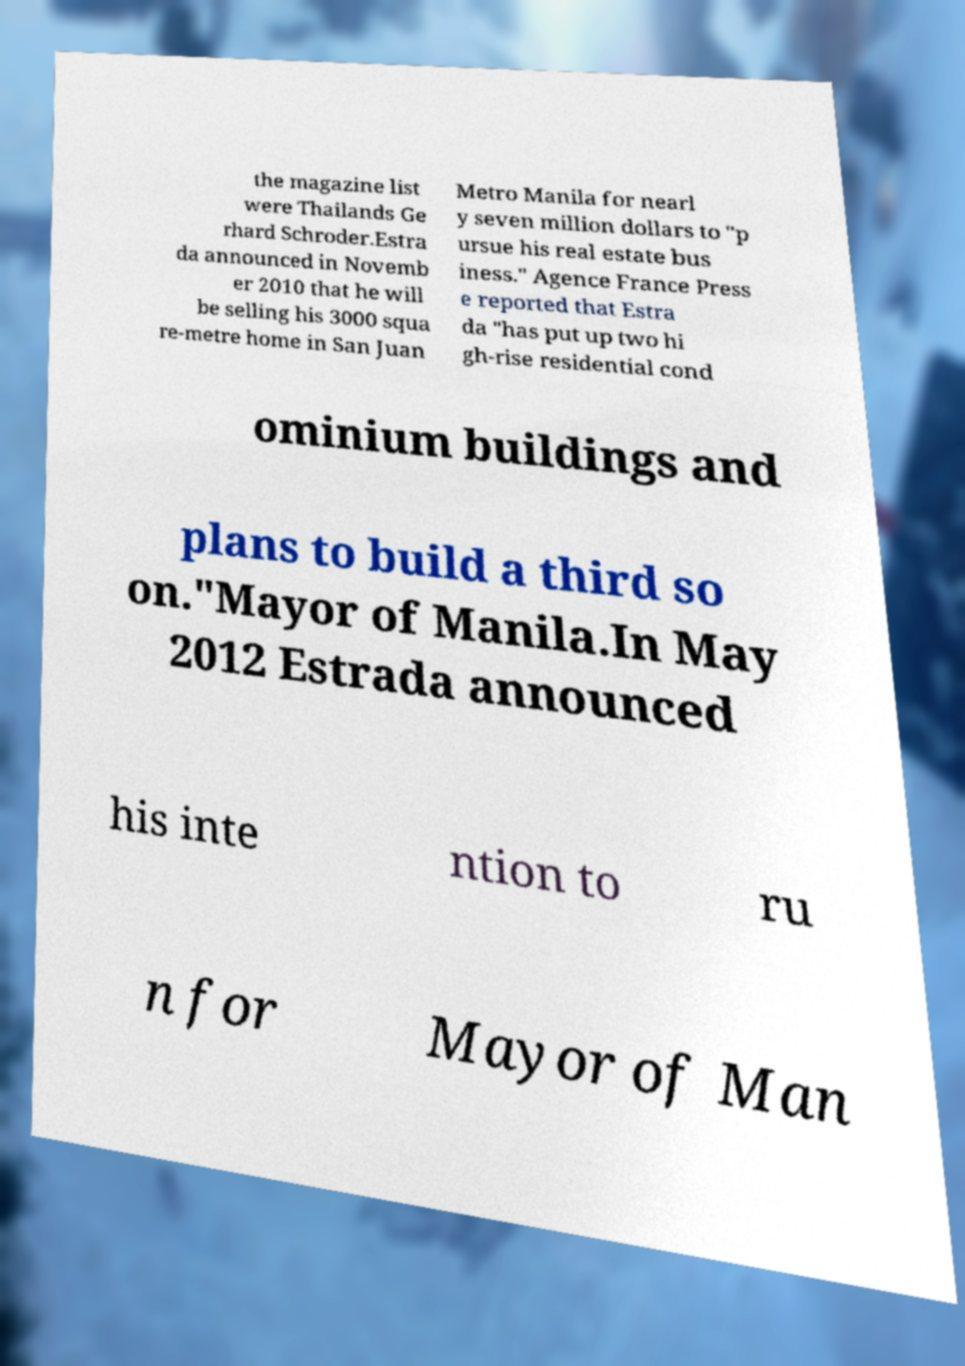There's text embedded in this image that I need extracted. Can you transcribe it verbatim? the magazine list were Thailands Ge rhard Schroder.Estra da announced in Novemb er 2010 that he will be selling his 3000 squa re-metre home in San Juan Metro Manila for nearl y seven million dollars to "p ursue his real estate bus iness." Agence France Press e reported that Estra da "has put up two hi gh-rise residential cond ominium buildings and plans to build a third so on."Mayor of Manila.In May 2012 Estrada announced his inte ntion to ru n for Mayor of Man 